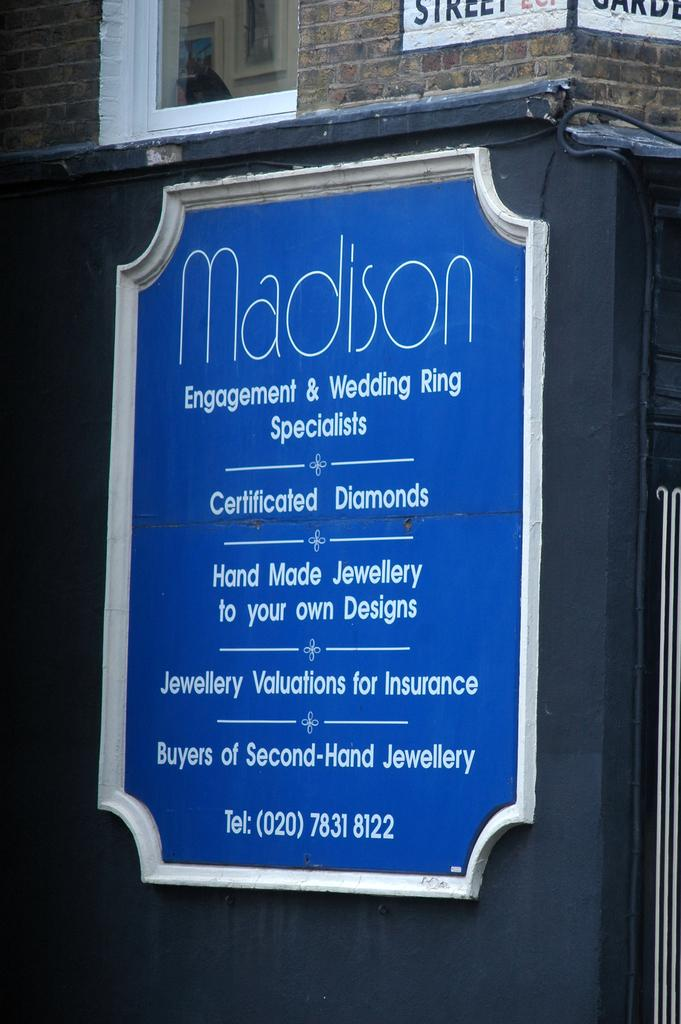What object is present in the image that has text on it? There is a nameplate in the image that has text on it. Where is the nameplate located in the image? The nameplate is on the wall of a building. What might the text on the nameplate indicate? The text on the nameplate might indicate the name of a person, business, or room. What type of stew is being served in the image? There is no stew present in the image; it only features a nameplate on a wall. 